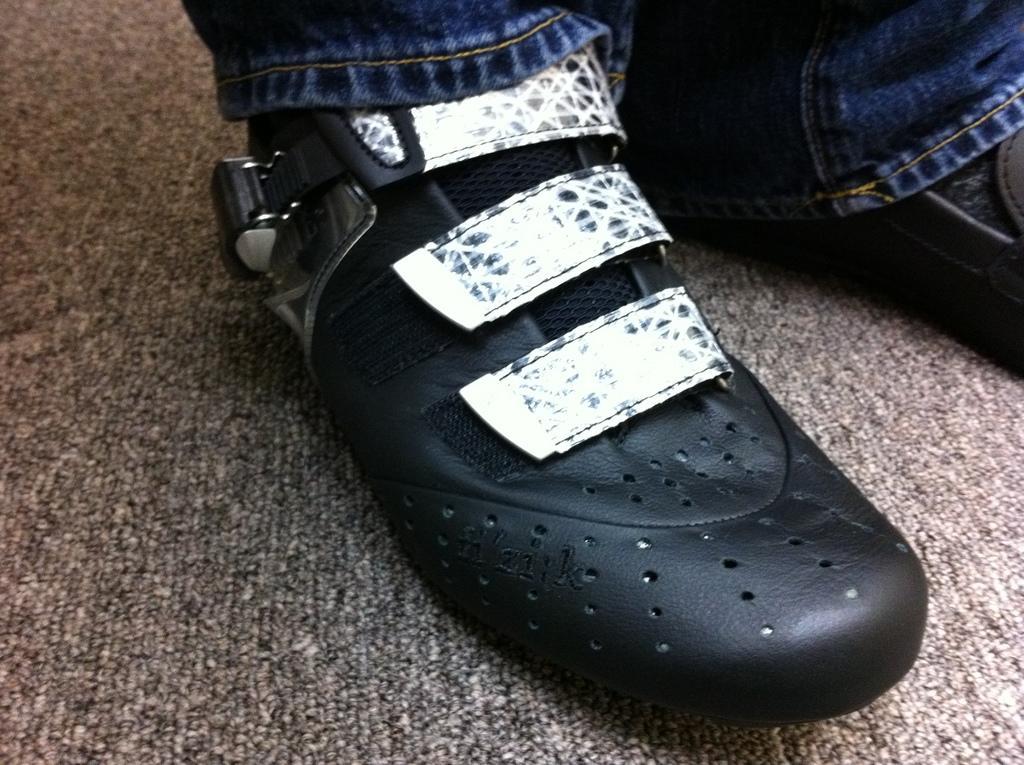How would you summarize this image in a sentence or two? In this image I can see person's legs on the floor. This image is taken in a room. 